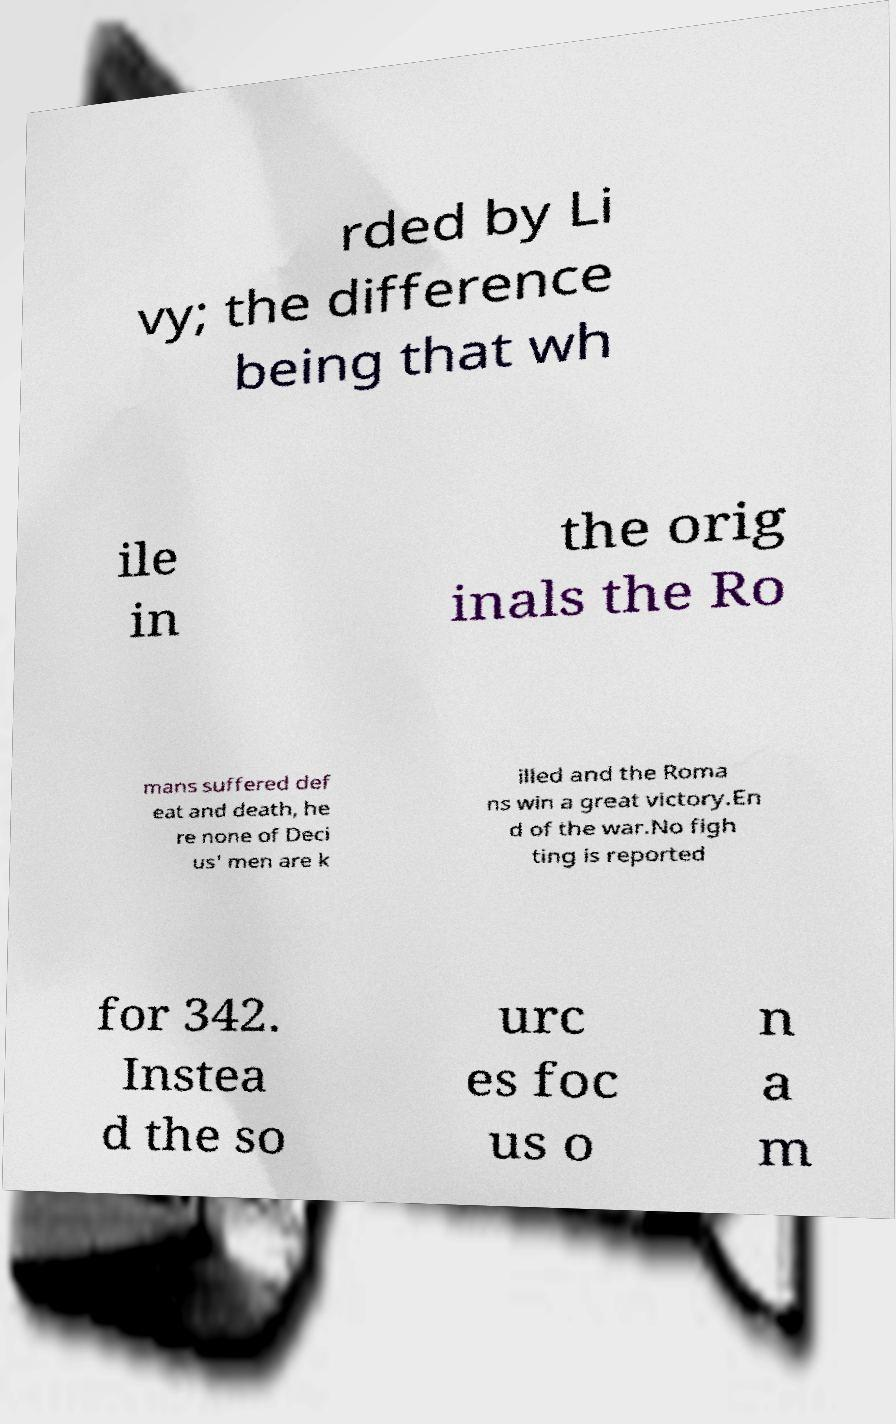I need the written content from this picture converted into text. Can you do that? rded by Li vy; the difference being that wh ile in the orig inals the Ro mans suffered def eat and death, he re none of Deci us' men are k illed and the Roma ns win a great victory.En d of the war.No figh ting is reported for 342. Instea d the so urc es foc us o n a m 